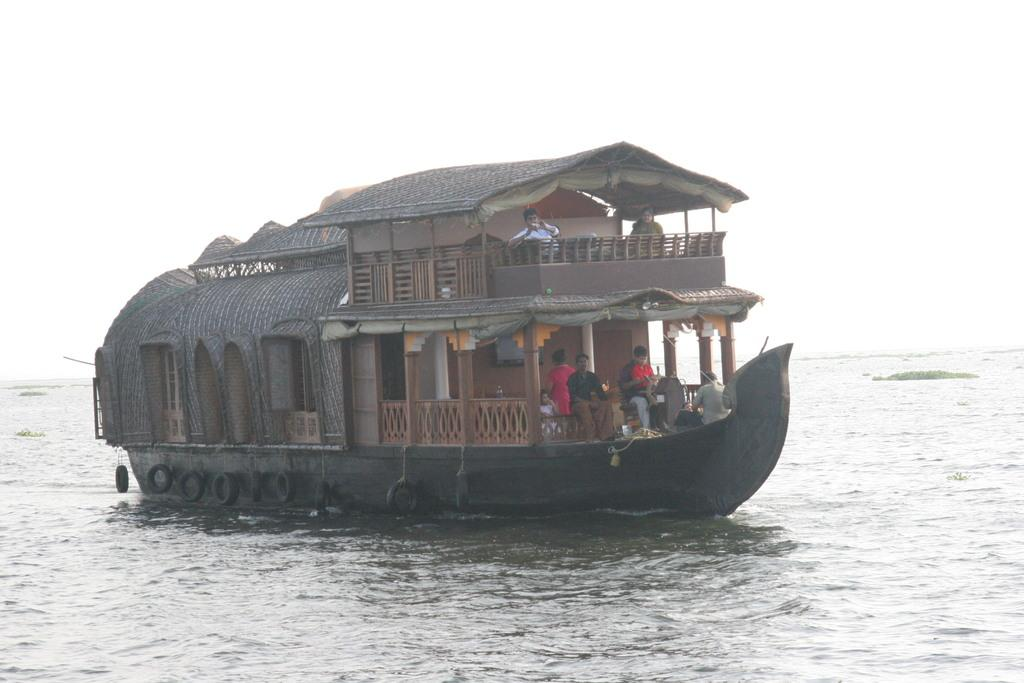What is the main subject of the image? The main subject of the image is a ship. Where is the ship located in the image? The ship is on the water in the image. Are there any people on the ship? Yes, there are people on the ship in the image. What are the people on the ship doing? The people on the ship are holding an object. What additional feature can be seen on the ship? There are tires tied to the ship in the image. What type of cat can be seen reacting to the spot on the ship? There is no cat present in the image, and therefore no reaction to a spot can be observed. 